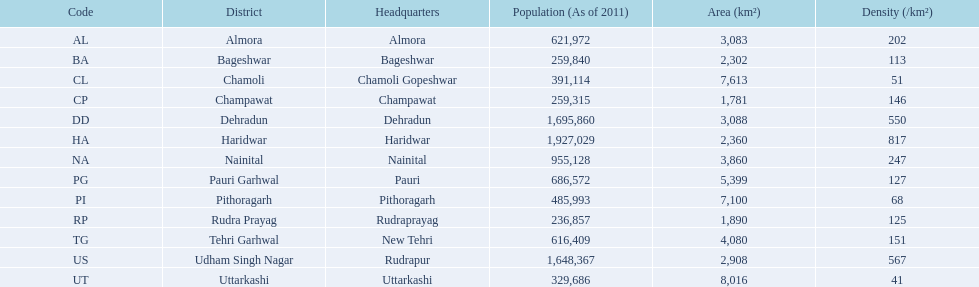Provide the count of districts with a region larger than 500 4. 